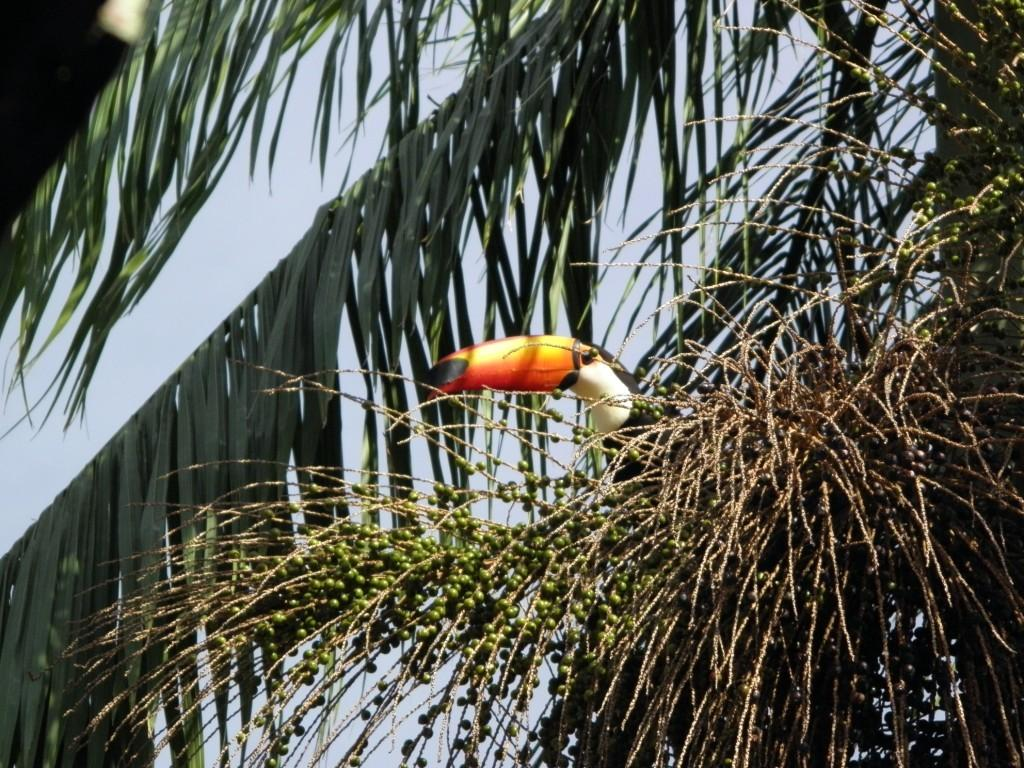What type of animal can be seen in the image? There is a bird in the image. Where is the bird located? The bird is on a tree. What can be seen in the background of the image? The sky is visible in the background of the image. What type of plane can be seen at the airport in the image? There is no plane or airport present in the image; it features a bird on a tree with the sky visible in the background. What smell is associated with the bird in the image? There is no information about the smell in the image, as it focuses on the visual aspects of the bird and its surroundings. 